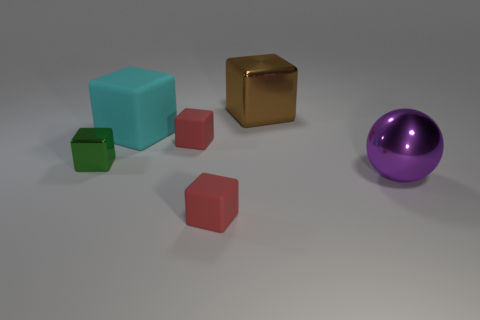Does the red matte cube in front of the big purple ball have the same size as the metallic cube that is on the left side of the cyan block?
Your response must be concise. Yes. How many cylinders are big brown metal things or purple things?
Ensure brevity in your answer.  0. Is the material of the big object that is left of the large brown block the same as the ball?
Ensure brevity in your answer.  No. What number of tiny objects are either red matte cubes or brown objects?
Give a very brief answer. 2. Are there more purple things on the right side of the brown metallic block than shiny balls that are left of the green thing?
Ensure brevity in your answer.  Yes. Do the metallic object that is behind the small green shiny object and the big matte cube have the same color?
Your answer should be compact. No. Are there more large cyan cubes behind the tiny green thing than tiny gray cubes?
Offer a terse response. Yes. Do the brown block and the cyan block have the same size?
Provide a short and direct response. Yes. There is a large cyan object that is the same shape as the small green thing; what material is it?
Your answer should be very brief. Rubber. Is there anything else that has the same material as the large purple ball?
Offer a very short reply. Yes. 